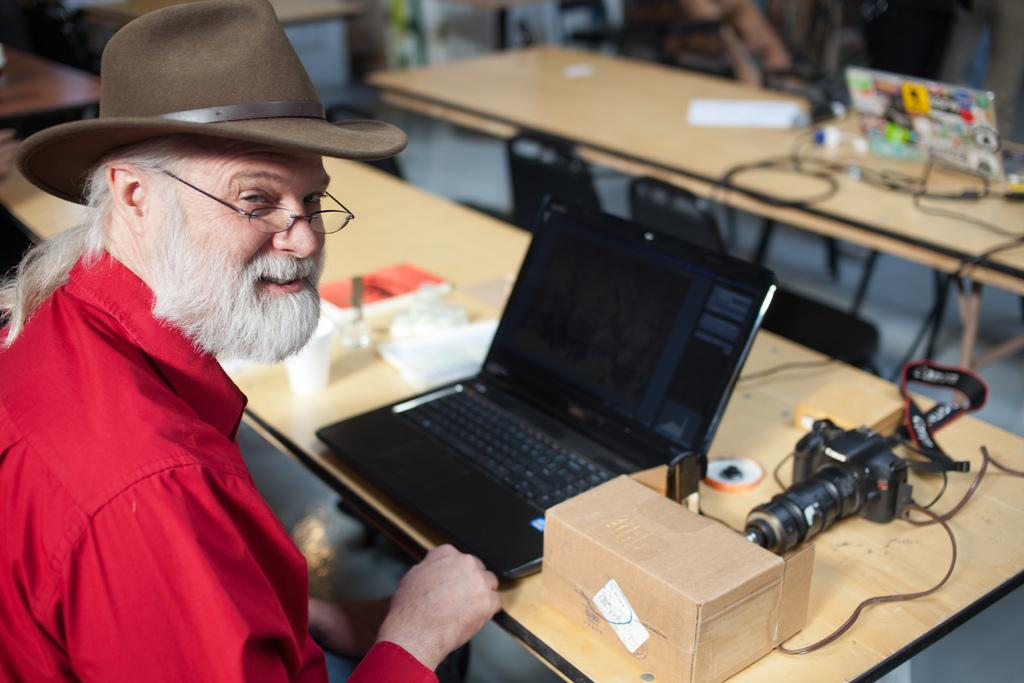Who is present in the image? There is a man in the image. What is the man wearing on his upper body? The man is wearing a red shirt. What type of headwear is the man wearing? The man is wearing a brown hat. Where is the man sitting in relation to the table? The man is sitting in front of a table. What electronic devices are on the table? There is a laptop and a camera on the table. How many balloons are floating above the man's head in the image? There are no balloons present in the image. What type of jar is sitting next to the laptop on the table? There is no jar present in the image; only a laptop and a camera are on the table. 